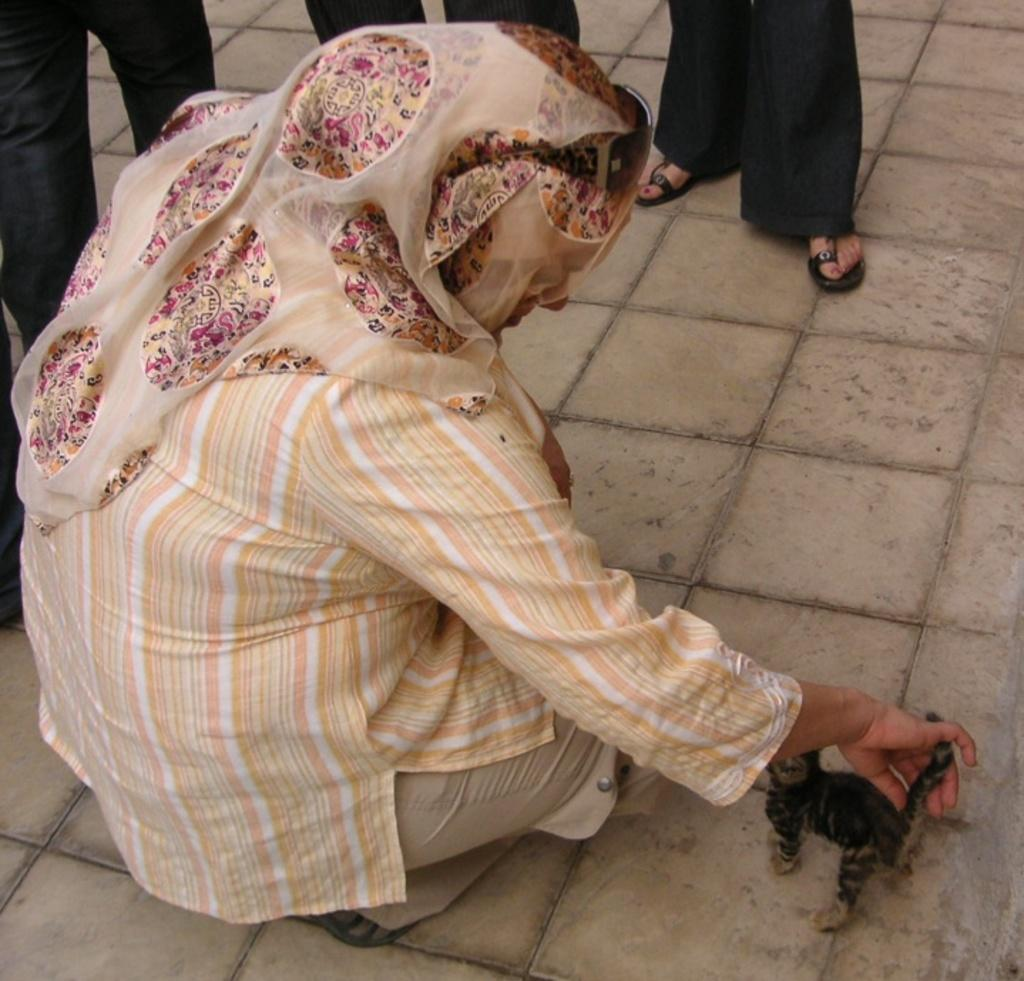What is the person in the image holding? The facts do not specify what the person is holding. Can you describe the people in the background of the image? There are people standing in the background of the image. What type of surface is visible at the bottom of the image? Tiles are visible at the bottom of the image. What time of day is it in the image? The facts do not provide any information about the time of day in the image. What type of question is being asked in the image? There is no indication of a question being asked in the image. 